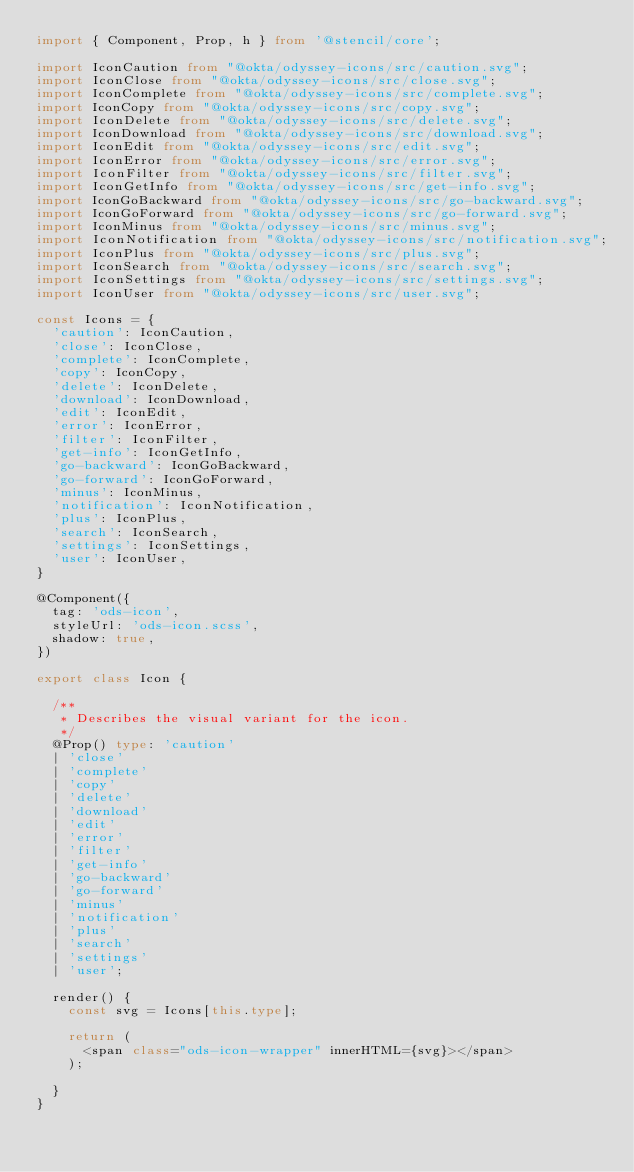<code> <loc_0><loc_0><loc_500><loc_500><_TypeScript_>import { Component, Prop, h } from '@stencil/core';

import IconCaution from "@okta/odyssey-icons/src/caution.svg";
import IconClose from "@okta/odyssey-icons/src/close.svg";
import IconComplete from "@okta/odyssey-icons/src/complete.svg";
import IconCopy from "@okta/odyssey-icons/src/copy.svg";
import IconDelete from "@okta/odyssey-icons/src/delete.svg";
import IconDownload from "@okta/odyssey-icons/src/download.svg";
import IconEdit from "@okta/odyssey-icons/src/edit.svg";
import IconError from "@okta/odyssey-icons/src/error.svg";
import IconFilter from "@okta/odyssey-icons/src/filter.svg";
import IconGetInfo from "@okta/odyssey-icons/src/get-info.svg";
import IconGoBackward from "@okta/odyssey-icons/src/go-backward.svg";
import IconGoForward from "@okta/odyssey-icons/src/go-forward.svg";
import IconMinus from "@okta/odyssey-icons/src/minus.svg";
import IconNotification from "@okta/odyssey-icons/src/notification.svg";
import IconPlus from "@okta/odyssey-icons/src/plus.svg";
import IconSearch from "@okta/odyssey-icons/src/search.svg";
import IconSettings from "@okta/odyssey-icons/src/settings.svg";
import IconUser from "@okta/odyssey-icons/src/user.svg";

const Icons = {
  'caution': IconCaution,
  'close': IconClose,
  'complete': IconComplete,
  'copy': IconCopy,
  'delete': IconDelete,
  'download': IconDownload,
  'edit': IconEdit,
  'error': IconError,
  'filter': IconFilter,
  'get-info': IconGetInfo,
  'go-backward': IconGoBackward,
  'go-forward': IconGoForward,
  'minus': IconMinus,
  'notification': IconNotification,
  'plus': IconPlus,
  'search': IconSearch,
  'settings': IconSettings,
  'user': IconUser,
}

@Component({
  tag: 'ods-icon',
  styleUrl: 'ods-icon.scss',
  shadow: true,
})

export class Icon {

  /**
   * Describes the visual variant for the icon.
   */
  @Prop() type: 'caution'
  | 'close'
  | 'complete'
  | 'copy'
  | 'delete'
  | 'download'
  | 'edit'
  | 'error'
  | 'filter'
  | 'get-info'
  | 'go-backward'
  | 'go-forward'
  | 'minus'
  | 'notification'
  | 'plus'
  | 'search'
  | 'settings'
  | 'user';

  render() {
    const svg = Icons[this.type];

    return (
      <span class="ods-icon-wrapper" innerHTML={svg}></span>
    );

  }
}
</code> 